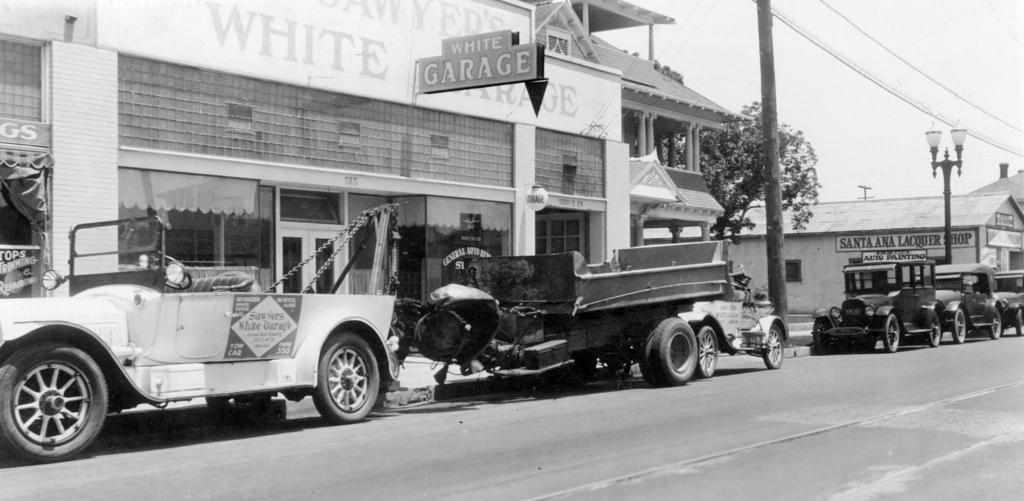What is the color scheme of the image? The image is black and white. What types of vehicles can be seen in the image? There are cars and trucks in the image. Where are the vehicles located in the image? The vehicles are on the side of the road. What structure is located beside the road? There is a building beside the road. What natural element is in the middle of the image? There is a tree in the middle of the image. What type of lighting is present in the image? Street lights are present in the image. What part of the natural environment is visible in the image? The sky is visible in the image. What type of meat can be seen hanging from the tree in the image? There is no meat hanging from the tree in the image; it is a tree with no additional objects or elements. 